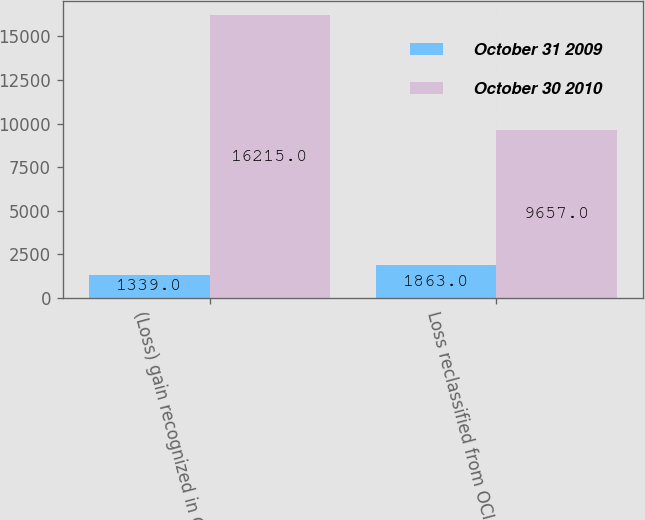<chart> <loc_0><loc_0><loc_500><loc_500><stacked_bar_chart><ecel><fcel>(Loss) gain recognized in OCI<fcel>Loss reclassified from OCI<nl><fcel>October 31 2009<fcel>1339<fcel>1863<nl><fcel>October 30 2010<fcel>16215<fcel>9657<nl></chart> 